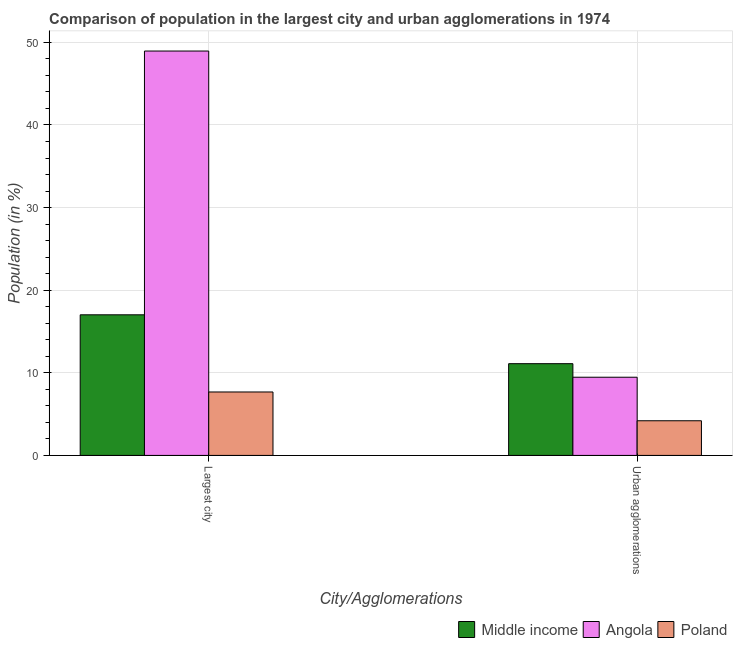How many groups of bars are there?
Keep it short and to the point. 2. How many bars are there on the 1st tick from the left?
Offer a terse response. 3. What is the label of the 1st group of bars from the left?
Your answer should be compact. Largest city. What is the population in urban agglomerations in Middle income?
Make the answer very short. 11.11. Across all countries, what is the maximum population in urban agglomerations?
Ensure brevity in your answer.  11.11. Across all countries, what is the minimum population in urban agglomerations?
Offer a terse response. 4.2. What is the total population in the largest city in the graph?
Give a very brief answer. 73.65. What is the difference between the population in urban agglomerations in Poland and that in Middle income?
Ensure brevity in your answer.  -6.91. What is the difference between the population in urban agglomerations in Poland and the population in the largest city in Middle income?
Offer a very short reply. -12.83. What is the average population in the largest city per country?
Your answer should be very brief. 24.55. What is the difference between the population in urban agglomerations and population in the largest city in Angola?
Give a very brief answer. -39.49. What is the ratio of the population in urban agglomerations in Middle income to that in Poland?
Your answer should be compact. 2.65. Is the population in urban agglomerations in Middle income less than that in Angola?
Provide a short and direct response. No. In how many countries, is the population in the largest city greater than the average population in the largest city taken over all countries?
Give a very brief answer. 1. What does the 3rd bar from the left in Largest city represents?
Offer a very short reply. Poland. What does the 2nd bar from the right in Urban agglomerations represents?
Your answer should be compact. Angola. How many countries are there in the graph?
Ensure brevity in your answer.  3. Are the values on the major ticks of Y-axis written in scientific E-notation?
Provide a short and direct response. No. Where does the legend appear in the graph?
Offer a terse response. Bottom right. How many legend labels are there?
Offer a terse response. 3. What is the title of the graph?
Provide a short and direct response. Comparison of population in the largest city and urban agglomerations in 1974. What is the label or title of the X-axis?
Offer a very short reply. City/Agglomerations. What is the label or title of the Y-axis?
Make the answer very short. Population (in %). What is the Population (in %) of Middle income in Largest city?
Offer a terse response. 17.02. What is the Population (in %) of Angola in Largest city?
Provide a succinct answer. 48.95. What is the Population (in %) in Poland in Largest city?
Your answer should be compact. 7.68. What is the Population (in %) of Middle income in Urban agglomerations?
Provide a succinct answer. 11.11. What is the Population (in %) of Angola in Urban agglomerations?
Your response must be concise. 9.47. What is the Population (in %) of Poland in Urban agglomerations?
Make the answer very short. 4.2. Across all City/Agglomerations, what is the maximum Population (in %) of Middle income?
Your answer should be very brief. 17.02. Across all City/Agglomerations, what is the maximum Population (in %) of Angola?
Your answer should be compact. 48.95. Across all City/Agglomerations, what is the maximum Population (in %) of Poland?
Provide a short and direct response. 7.68. Across all City/Agglomerations, what is the minimum Population (in %) of Middle income?
Give a very brief answer. 11.11. Across all City/Agglomerations, what is the minimum Population (in %) in Angola?
Provide a short and direct response. 9.47. Across all City/Agglomerations, what is the minimum Population (in %) of Poland?
Offer a very short reply. 4.2. What is the total Population (in %) of Middle income in the graph?
Keep it short and to the point. 28.13. What is the total Population (in %) in Angola in the graph?
Your response must be concise. 58.42. What is the total Population (in %) in Poland in the graph?
Provide a succinct answer. 11.88. What is the difference between the Population (in %) of Middle income in Largest city and that in Urban agglomerations?
Your answer should be very brief. 5.92. What is the difference between the Population (in %) of Angola in Largest city and that in Urban agglomerations?
Give a very brief answer. 39.49. What is the difference between the Population (in %) in Poland in Largest city and that in Urban agglomerations?
Provide a short and direct response. 3.48. What is the difference between the Population (in %) in Middle income in Largest city and the Population (in %) in Angola in Urban agglomerations?
Ensure brevity in your answer.  7.55. What is the difference between the Population (in %) of Middle income in Largest city and the Population (in %) of Poland in Urban agglomerations?
Make the answer very short. 12.83. What is the difference between the Population (in %) of Angola in Largest city and the Population (in %) of Poland in Urban agglomerations?
Give a very brief answer. 44.76. What is the average Population (in %) of Middle income per City/Agglomerations?
Give a very brief answer. 14.06. What is the average Population (in %) in Angola per City/Agglomerations?
Provide a succinct answer. 29.21. What is the average Population (in %) of Poland per City/Agglomerations?
Make the answer very short. 5.94. What is the difference between the Population (in %) in Middle income and Population (in %) in Angola in Largest city?
Give a very brief answer. -31.93. What is the difference between the Population (in %) in Middle income and Population (in %) in Poland in Largest city?
Provide a succinct answer. 9.34. What is the difference between the Population (in %) of Angola and Population (in %) of Poland in Largest city?
Offer a very short reply. 41.27. What is the difference between the Population (in %) of Middle income and Population (in %) of Angola in Urban agglomerations?
Give a very brief answer. 1.64. What is the difference between the Population (in %) of Middle income and Population (in %) of Poland in Urban agglomerations?
Offer a very short reply. 6.91. What is the difference between the Population (in %) in Angola and Population (in %) in Poland in Urban agglomerations?
Keep it short and to the point. 5.27. What is the ratio of the Population (in %) of Middle income in Largest city to that in Urban agglomerations?
Offer a terse response. 1.53. What is the ratio of the Population (in %) of Angola in Largest city to that in Urban agglomerations?
Make the answer very short. 5.17. What is the ratio of the Population (in %) of Poland in Largest city to that in Urban agglomerations?
Your answer should be very brief. 1.83. What is the difference between the highest and the second highest Population (in %) of Middle income?
Keep it short and to the point. 5.92. What is the difference between the highest and the second highest Population (in %) of Angola?
Provide a short and direct response. 39.49. What is the difference between the highest and the second highest Population (in %) of Poland?
Your response must be concise. 3.48. What is the difference between the highest and the lowest Population (in %) of Middle income?
Keep it short and to the point. 5.92. What is the difference between the highest and the lowest Population (in %) of Angola?
Keep it short and to the point. 39.49. What is the difference between the highest and the lowest Population (in %) of Poland?
Offer a very short reply. 3.48. 